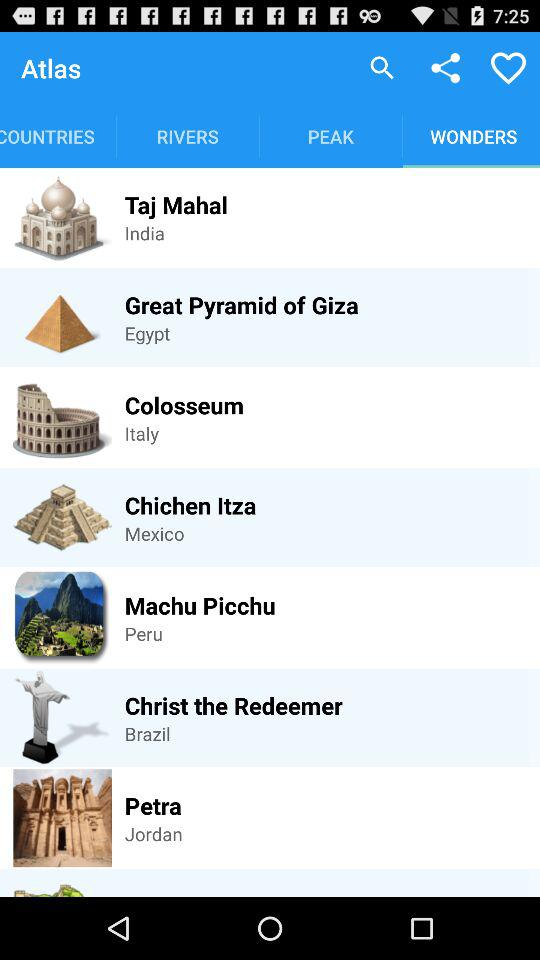Which tab is selected? The selected tab is "WONDERS". 